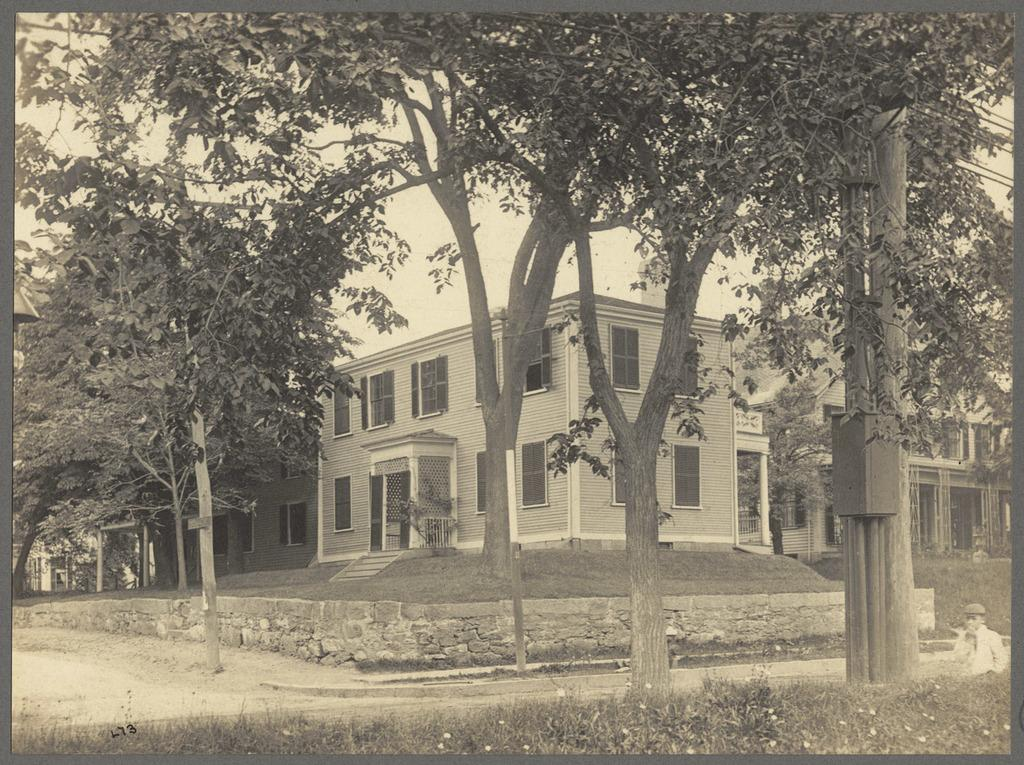What is the color scheme of the image? The image is black and white. What type of structures can be seen in the image? There are houses in the image. What type of vegetation is present in the image? There are trees in the image. What type of ground cover is at the bottom of the image? There is grass at the bottom of the image. Can you see anyone saying good-bye in the image? There is no indication of anyone saying good-bye in the image, as it is a black and white image of houses, trees, and grass. What season is depicted in the image, considering the presence of trees and grass? The image does not depict a specific season, as it is in black and white and does not show any seasonal changes in the trees or grass. 